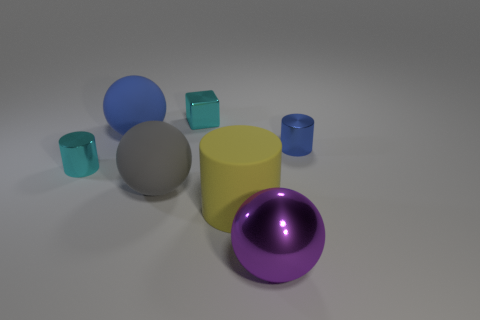Are there any purple things that have the same shape as the gray object?
Provide a short and direct response. Yes. There is a cylinder that is the same size as the purple metal object; what color is it?
Provide a short and direct response. Yellow. How big is the shiny cylinder that is left of the shiny sphere?
Provide a short and direct response. Small. There is a cylinder that is on the right side of the yellow rubber thing; is there a metal object that is left of it?
Keep it short and to the point. Yes. Do the cyan object that is behind the blue metal thing and the cyan cylinder have the same material?
Make the answer very short. Yes. What number of things are to the left of the tiny blue object and behind the cyan cylinder?
Offer a terse response. 2. How many tiny cyan objects have the same material as the large purple sphere?
Offer a terse response. 2. There is a small cube that is made of the same material as the big purple thing; what color is it?
Give a very brief answer. Cyan. Is the number of blue rubber objects less than the number of cyan objects?
Keep it short and to the point. Yes. The big sphere that is behind the small cylinder that is left of the ball that is on the right side of the large yellow matte cylinder is made of what material?
Your answer should be compact. Rubber. 